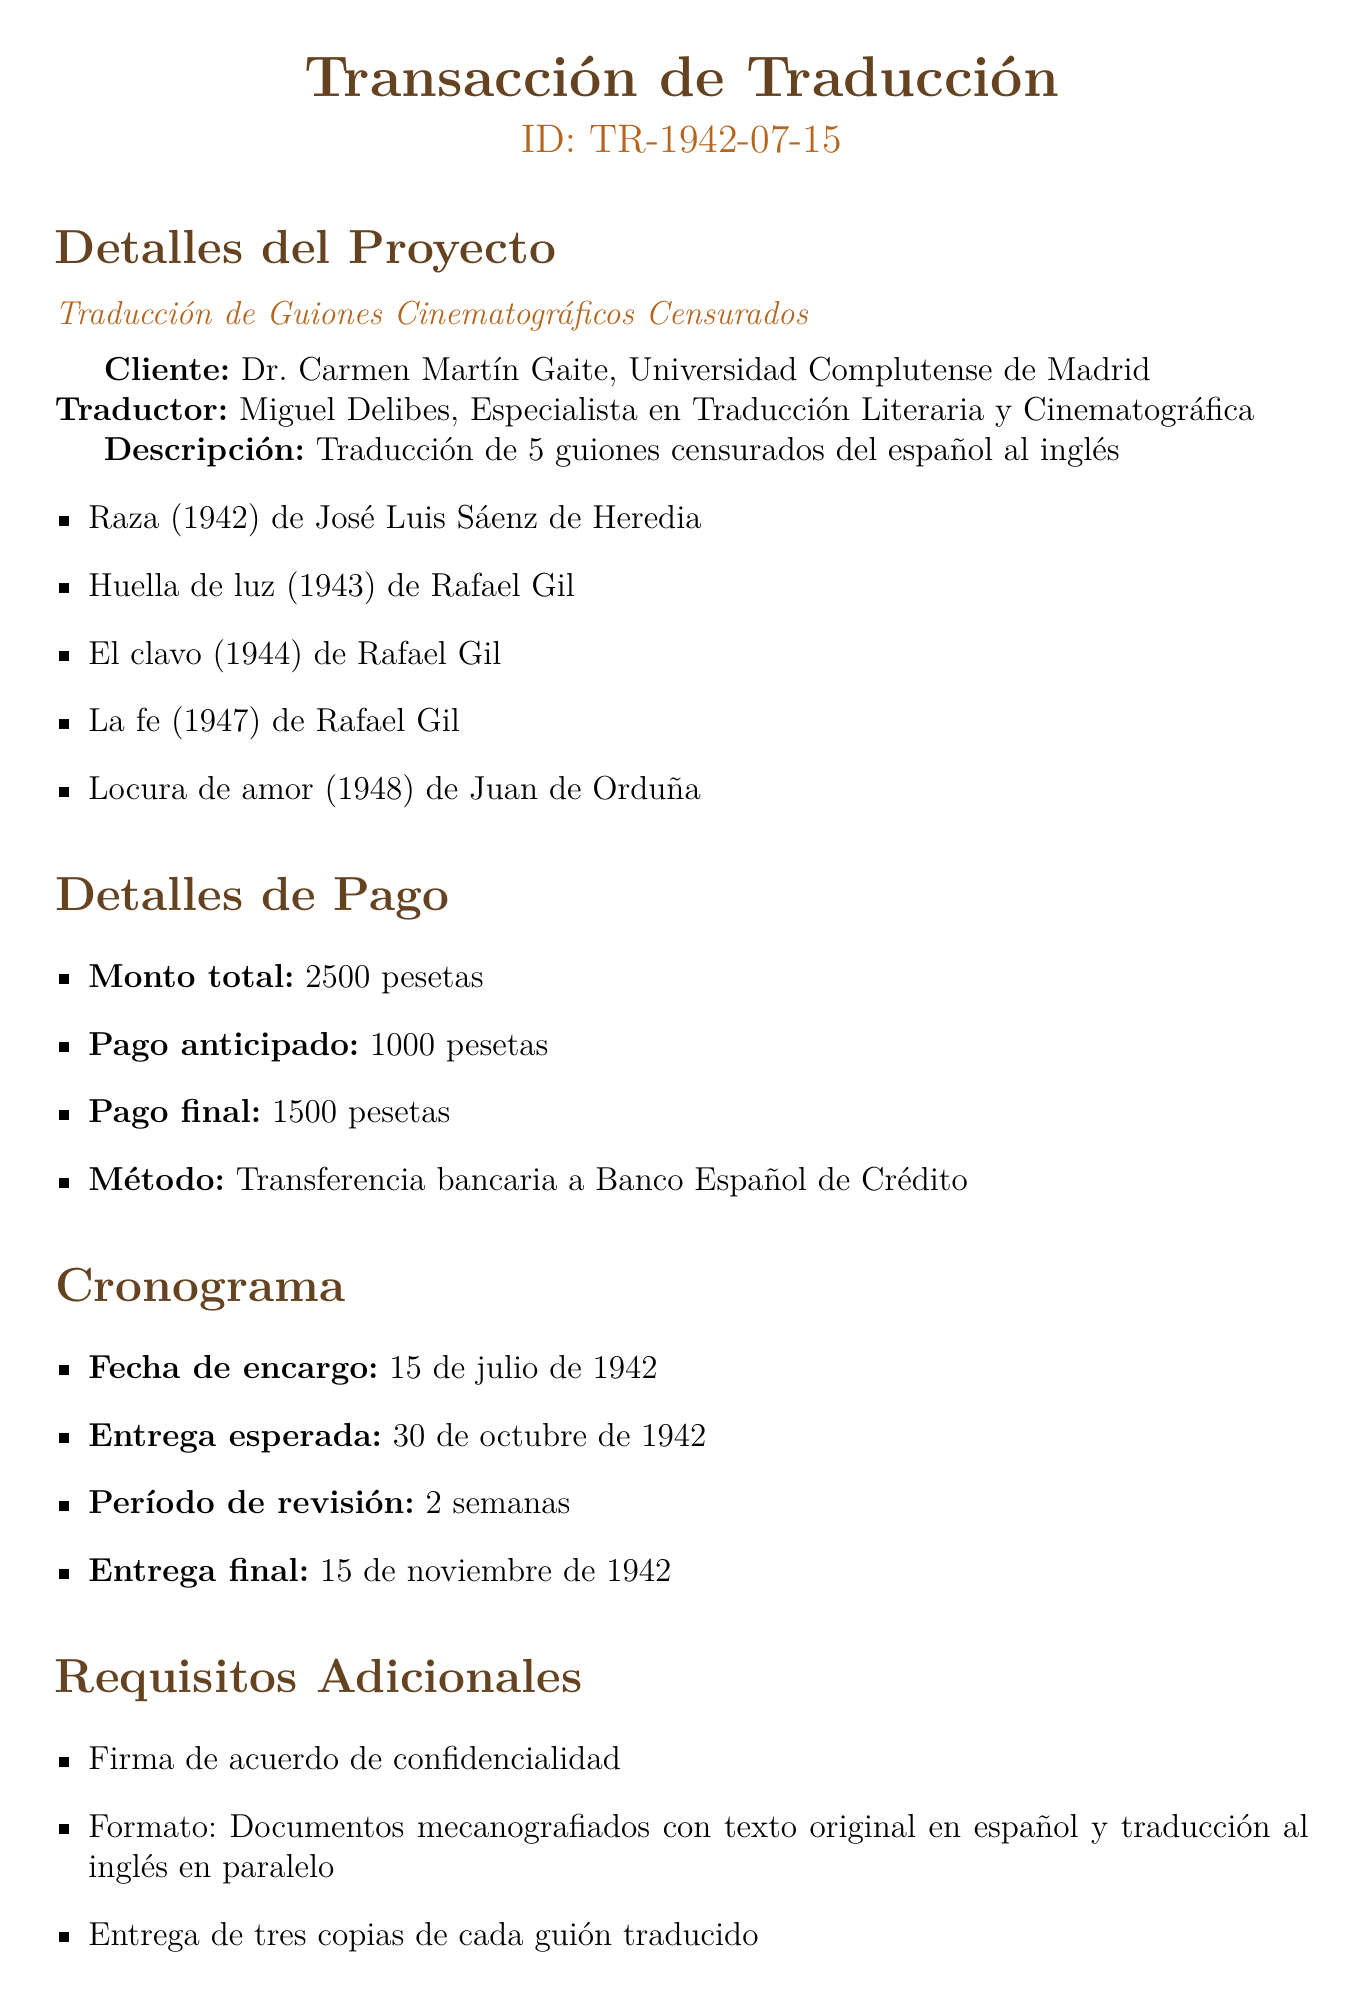What is the transaction ID? The transaction ID is stated at the beginning of the document, indicating the unique identification of this transaction.
Answer: TR-1942-07-15 Who is the translator? The translator's name and specialization are clearly mentioned, outlining who will be handling the translation work.
Answer: Miguel Delibes How many scripts are to be translated? The total number of scripts is specified in the project details, highlighting the scope of work required.
Answer: 5 What is the advance payment amount? The advance payment amount is listed under payment details in the document.
Answer: 1000 pesetas When is the expected delivery date? The expected delivery date is mentioned in the timeline section of the document.
Answer: 1942-10-30 What is the payment method? The payment method is noted as part of the payment details, informing how the payment will be processed.
Answer: Bank transfer to Banco Español de Crédito What is the revision period for the translations? The revision period is outlined within the timeline section of the document, indicating time allotted for reviews.
Answer: 2 weeks What type of agreement must the translator sign? The requirement for a specific agreement is stated in the additional requirements, emphasizing confidentiality needs.
Answer: Non-disclosure agreement Which censorship body was involved? The document mentions the body responsible for censorship, detailing the bureaucratic context related to the films.
Answer: Junta Superior de Censura Cinematográfica 